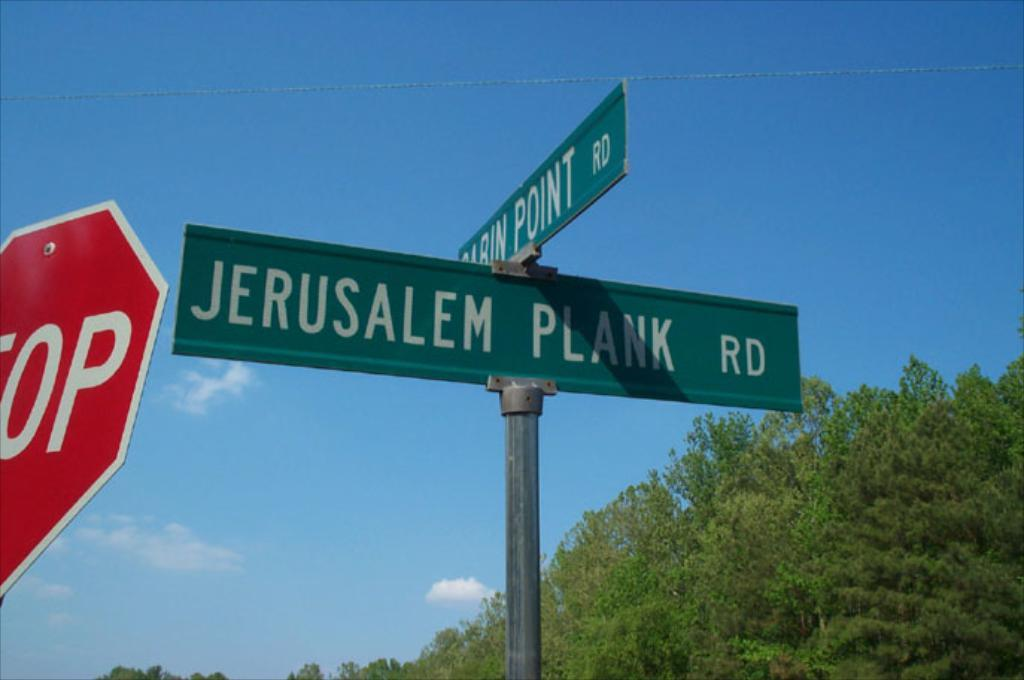How many address boards can be seen in the image? There are two address boards in the image. What is attached to poles in the image? There is a signboard attached to poles in the image. What type of natural vegetation is present in the image? Trees are present in the image. What is visible at the top of the image? The sky is visible in the image. What type of net is being used to catch fish in the image? There is no net or fishing activity present in the image. Can you tell me where the church is located in the image? There is no church present in the image. 